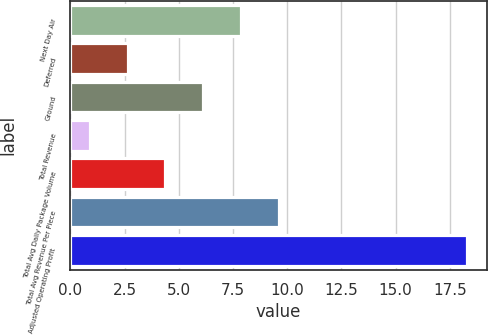Convert chart. <chart><loc_0><loc_0><loc_500><loc_500><bar_chart><fcel>Next Day Air<fcel>Deferred<fcel>Ground<fcel>Total Revenue<fcel>Total Avg Daily Package Volume<fcel>Total Avg Revenue Per Piece<fcel>Adjusted Operating Profit<nl><fcel>7.86<fcel>2.64<fcel>6.12<fcel>0.9<fcel>4.38<fcel>9.6<fcel>18.3<nl></chart> 